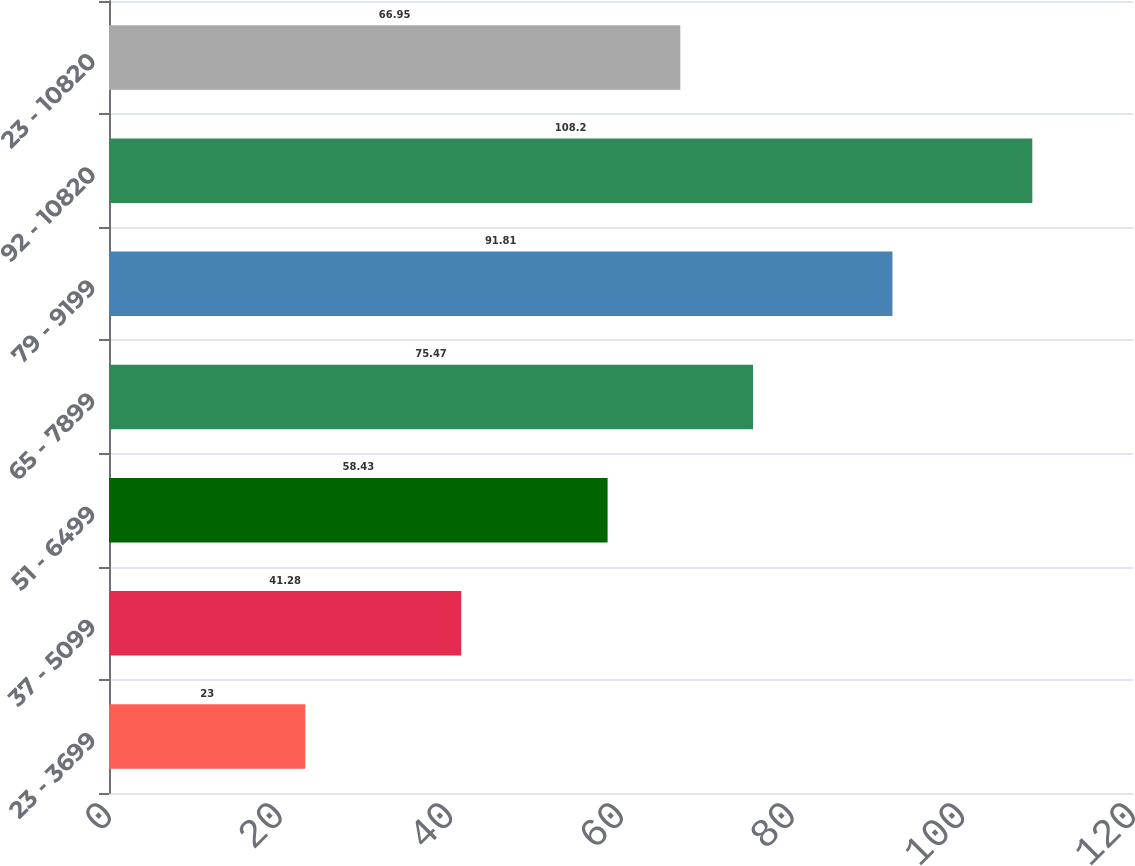Convert chart to OTSL. <chart><loc_0><loc_0><loc_500><loc_500><bar_chart><fcel>23 - 3699<fcel>37 - 5099<fcel>51 - 6499<fcel>65 - 7899<fcel>79 - 9199<fcel>92 - 10820<fcel>23 - 10820<nl><fcel>23<fcel>41.28<fcel>58.43<fcel>75.47<fcel>91.81<fcel>108.2<fcel>66.95<nl></chart> 